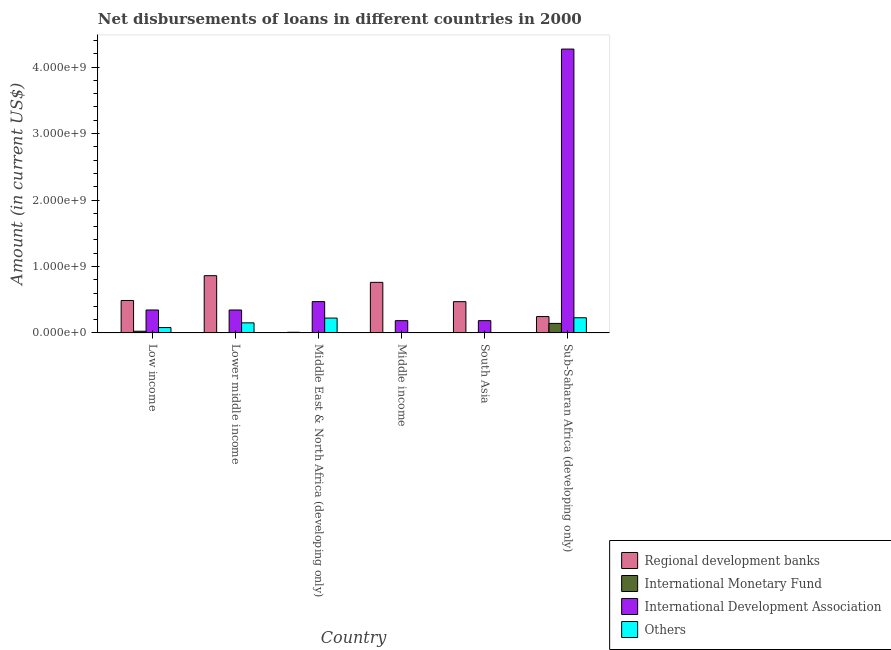Are the number of bars on each tick of the X-axis equal?
Give a very brief answer. No. How many bars are there on the 1st tick from the left?
Provide a short and direct response. 4. How many bars are there on the 6th tick from the right?
Your answer should be very brief. 4. What is the amount of loan disimbursed by regional development banks in Sub-Saharan Africa (developing only)?
Provide a succinct answer. 2.46e+08. Across all countries, what is the maximum amount of loan disimbursed by other organisations?
Offer a terse response. 2.28e+08. In which country was the amount of loan disimbursed by international monetary fund maximum?
Offer a terse response. Sub-Saharan Africa (developing only). What is the total amount of loan disimbursed by international monetary fund in the graph?
Offer a very short reply. 1.73e+08. What is the difference between the amount of loan disimbursed by regional development banks in Low income and that in Sub-Saharan Africa (developing only)?
Make the answer very short. 2.42e+08. What is the difference between the amount of loan disimbursed by international monetary fund in Low income and the amount of loan disimbursed by other organisations in Middle income?
Your answer should be compact. 2.57e+07. What is the average amount of loan disimbursed by regional development banks per country?
Keep it short and to the point. 4.73e+08. What is the difference between the amount of loan disimbursed by regional development banks and amount of loan disimbursed by international monetary fund in Low income?
Ensure brevity in your answer.  4.63e+08. In how many countries, is the amount of loan disimbursed by international development association greater than 4200000000 US$?
Give a very brief answer. 1. What is the ratio of the amount of loan disimbursed by regional development banks in Lower middle income to that in Sub-Saharan Africa (developing only)?
Ensure brevity in your answer.  3.5. Is the amount of loan disimbursed by international development association in Low income less than that in Middle income?
Offer a very short reply. No. Is the difference between the amount of loan disimbursed by regional development banks in Lower middle income and Sub-Saharan Africa (developing only) greater than the difference between the amount of loan disimbursed by other organisations in Lower middle income and Sub-Saharan Africa (developing only)?
Provide a short and direct response. Yes. What is the difference between the highest and the second highest amount of loan disimbursed by regional development banks?
Your answer should be compact. 1.01e+08. What is the difference between the highest and the lowest amount of loan disimbursed by other organisations?
Keep it short and to the point. 2.28e+08. In how many countries, is the amount of loan disimbursed by other organisations greater than the average amount of loan disimbursed by other organisations taken over all countries?
Offer a very short reply. 3. Is it the case that in every country, the sum of the amount of loan disimbursed by regional development banks and amount of loan disimbursed by international monetary fund is greater than the amount of loan disimbursed by international development association?
Ensure brevity in your answer.  No. Are the values on the major ticks of Y-axis written in scientific E-notation?
Your answer should be very brief. Yes. Does the graph contain any zero values?
Provide a short and direct response. Yes. Does the graph contain grids?
Your answer should be very brief. No. How are the legend labels stacked?
Provide a succinct answer. Vertical. What is the title of the graph?
Offer a very short reply. Net disbursements of loans in different countries in 2000. Does "Insurance services" appear as one of the legend labels in the graph?
Your answer should be compact. No. What is the label or title of the X-axis?
Provide a short and direct response. Country. What is the label or title of the Y-axis?
Your answer should be very brief. Amount (in current US$). What is the Amount (in current US$) in Regional development banks in Low income?
Your answer should be compact. 4.88e+08. What is the Amount (in current US$) of International Monetary Fund in Low income?
Your response must be concise. 2.57e+07. What is the Amount (in current US$) of International Development Association in Low income?
Ensure brevity in your answer.  3.45e+08. What is the Amount (in current US$) of Others in Low income?
Your answer should be very brief. 8.07e+07. What is the Amount (in current US$) in Regional development banks in Lower middle income?
Provide a short and direct response. 8.62e+08. What is the Amount (in current US$) of International Monetary Fund in Lower middle income?
Make the answer very short. 0. What is the Amount (in current US$) of International Development Association in Lower middle income?
Keep it short and to the point. 3.45e+08. What is the Amount (in current US$) in Others in Lower middle income?
Make the answer very short. 1.52e+08. What is the Amount (in current US$) in Regional development banks in Middle East & North Africa (developing only)?
Ensure brevity in your answer.  1.01e+07. What is the Amount (in current US$) in International Monetary Fund in Middle East & North Africa (developing only)?
Offer a terse response. 3.60e+06. What is the Amount (in current US$) of International Development Association in Middle East & North Africa (developing only)?
Provide a short and direct response. 4.71e+08. What is the Amount (in current US$) of Others in Middle East & North Africa (developing only)?
Your answer should be very brief. 2.24e+08. What is the Amount (in current US$) in Regional development banks in Middle income?
Your answer should be compact. 7.61e+08. What is the Amount (in current US$) of International Development Association in Middle income?
Give a very brief answer. 1.85e+08. What is the Amount (in current US$) in Regional development banks in South Asia?
Provide a succinct answer. 4.71e+08. What is the Amount (in current US$) in International Monetary Fund in South Asia?
Keep it short and to the point. 0. What is the Amount (in current US$) in International Development Association in South Asia?
Your response must be concise. 1.85e+08. What is the Amount (in current US$) of Others in South Asia?
Your answer should be compact. 0. What is the Amount (in current US$) of Regional development banks in Sub-Saharan Africa (developing only)?
Offer a terse response. 2.46e+08. What is the Amount (in current US$) in International Monetary Fund in Sub-Saharan Africa (developing only)?
Give a very brief answer. 1.43e+08. What is the Amount (in current US$) of International Development Association in Sub-Saharan Africa (developing only)?
Provide a short and direct response. 4.27e+09. What is the Amount (in current US$) in Others in Sub-Saharan Africa (developing only)?
Offer a very short reply. 2.28e+08. Across all countries, what is the maximum Amount (in current US$) in Regional development banks?
Keep it short and to the point. 8.62e+08. Across all countries, what is the maximum Amount (in current US$) of International Monetary Fund?
Give a very brief answer. 1.43e+08. Across all countries, what is the maximum Amount (in current US$) of International Development Association?
Provide a succinct answer. 4.27e+09. Across all countries, what is the maximum Amount (in current US$) in Others?
Provide a short and direct response. 2.28e+08. Across all countries, what is the minimum Amount (in current US$) in Regional development banks?
Provide a short and direct response. 1.01e+07. Across all countries, what is the minimum Amount (in current US$) of International Development Association?
Keep it short and to the point. 1.85e+08. Across all countries, what is the minimum Amount (in current US$) of Others?
Your response must be concise. 0. What is the total Amount (in current US$) in Regional development banks in the graph?
Make the answer very short. 2.84e+09. What is the total Amount (in current US$) of International Monetary Fund in the graph?
Your answer should be very brief. 1.73e+08. What is the total Amount (in current US$) in International Development Association in the graph?
Your answer should be very brief. 5.80e+09. What is the total Amount (in current US$) of Others in the graph?
Keep it short and to the point. 6.85e+08. What is the difference between the Amount (in current US$) in Regional development banks in Low income and that in Lower middle income?
Keep it short and to the point. -3.73e+08. What is the difference between the Amount (in current US$) in International Development Association in Low income and that in Lower middle income?
Give a very brief answer. 0. What is the difference between the Amount (in current US$) in Others in Low income and that in Lower middle income?
Give a very brief answer. -7.11e+07. What is the difference between the Amount (in current US$) in Regional development banks in Low income and that in Middle East & North Africa (developing only)?
Your answer should be very brief. 4.78e+08. What is the difference between the Amount (in current US$) of International Monetary Fund in Low income and that in Middle East & North Africa (developing only)?
Offer a very short reply. 2.22e+07. What is the difference between the Amount (in current US$) in International Development Association in Low income and that in Middle East & North Africa (developing only)?
Your response must be concise. -1.26e+08. What is the difference between the Amount (in current US$) of Others in Low income and that in Middle East & North Africa (developing only)?
Ensure brevity in your answer.  -1.43e+08. What is the difference between the Amount (in current US$) in Regional development banks in Low income and that in Middle income?
Ensure brevity in your answer.  -2.73e+08. What is the difference between the Amount (in current US$) in International Development Association in Low income and that in Middle income?
Provide a short and direct response. 1.60e+08. What is the difference between the Amount (in current US$) in Regional development banks in Low income and that in South Asia?
Keep it short and to the point. 1.75e+07. What is the difference between the Amount (in current US$) in International Development Association in Low income and that in South Asia?
Your answer should be very brief. 1.60e+08. What is the difference between the Amount (in current US$) of Regional development banks in Low income and that in Sub-Saharan Africa (developing only)?
Offer a terse response. 2.42e+08. What is the difference between the Amount (in current US$) in International Monetary Fund in Low income and that in Sub-Saharan Africa (developing only)?
Offer a terse response. -1.18e+08. What is the difference between the Amount (in current US$) of International Development Association in Low income and that in Sub-Saharan Africa (developing only)?
Offer a terse response. -3.93e+09. What is the difference between the Amount (in current US$) in Others in Low income and that in Sub-Saharan Africa (developing only)?
Your answer should be very brief. -1.48e+08. What is the difference between the Amount (in current US$) in Regional development banks in Lower middle income and that in Middle East & North Africa (developing only)?
Offer a very short reply. 8.52e+08. What is the difference between the Amount (in current US$) in International Development Association in Lower middle income and that in Middle East & North Africa (developing only)?
Ensure brevity in your answer.  -1.26e+08. What is the difference between the Amount (in current US$) of Others in Lower middle income and that in Middle East & North Africa (developing only)?
Offer a terse response. -7.19e+07. What is the difference between the Amount (in current US$) of Regional development banks in Lower middle income and that in Middle income?
Keep it short and to the point. 1.01e+08. What is the difference between the Amount (in current US$) in International Development Association in Lower middle income and that in Middle income?
Your response must be concise. 1.60e+08. What is the difference between the Amount (in current US$) of Regional development banks in Lower middle income and that in South Asia?
Keep it short and to the point. 3.91e+08. What is the difference between the Amount (in current US$) in International Development Association in Lower middle income and that in South Asia?
Your response must be concise. 1.60e+08. What is the difference between the Amount (in current US$) of Regional development banks in Lower middle income and that in Sub-Saharan Africa (developing only)?
Ensure brevity in your answer.  6.15e+08. What is the difference between the Amount (in current US$) in International Development Association in Lower middle income and that in Sub-Saharan Africa (developing only)?
Make the answer very short. -3.93e+09. What is the difference between the Amount (in current US$) of Others in Lower middle income and that in Sub-Saharan Africa (developing only)?
Offer a terse response. -7.66e+07. What is the difference between the Amount (in current US$) of Regional development banks in Middle East & North Africa (developing only) and that in Middle income?
Your response must be concise. -7.51e+08. What is the difference between the Amount (in current US$) of International Development Association in Middle East & North Africa (developing only) and that in Middle income?
Provide a succinct answer. 2.86e+08. What is the difference between the Amount (in current US$) of Regional development banks in Middle East & North Africa (developing only) and that in South Asia?
Provide a short and direct response. -4.61e+08. What is the difference between the Amount (in current US$) in International Development Association in Middle East & North Africa (developing only) and that in South Asia?
Your answer should be compact. 2.86e+08. What is the difference between the Amount (in current US$) in Regional development banks in Middle East & North Africa (developing only) and that in Sub-Saharan Africa (developing only)?
Offer a terse response. -2.36e+08. What is the difference between the Amount (in current US$) in International Monetary Fund in Middle East & North Africa (developing only) and that in Sub-Saharan Africa (developing only)?
Your response must be concise. -1.40e+08. What is the difference between the Amount (in current US$) of International Development Association in Middle East & North Africa (developing only) and that in Sub-Saharan Africa (developing only)?
Provide a succinct answer. -3.80e+09. What is the difference between the Amount (in current US$) in Others in Middle East & North Africa (developing only) and that in Sub-Saharan Africa (developing only)?
Offer a very short reply. -4.69e+06. What is the difference between the Amount (in current US$) of Regional development banks in Middle income and that in South Asia?
Make the answer very short. 2.90e+08. What is the difference between the Amount (in current US$) in International Development Association in Middle income and that in South Asia?
Your response must be concise. 0. What is the difference between the Amount (in current US$) of Regional development banks in Middle income and that in Sub-Saharan Africa (developing only)?
Your answer should be compact. 5.15e+08. What is the difference between the Amount (in current US$) in International Development Association in Middle income and that in Sub-Saharan Africa (developing only)?
Keep it short and to the point. -4.09e+09. What is the difference between the Amount (in current US$) of Regional development banks in South Asia and that in Sub-Saharan Africa (developing only)?
Ensure brevity in your answer.  2.24e+08. What is the difference between the Amount (in current US$) of International Development Association in South Asia and that in Sub-Saharan Africa (developing only)?
Ensure brevity in your answer.  -4.09e+09. What is the difference between the Amount (in current US$) in Regional development banks in Low income and the Amount (in current US$) in International Development Association in Lower middle income?
Provide a short and direct response. 1.43e+08. What is the difference between the Amount (in current US$) of Regional development banks in Low income and the Amount (in current US$) of Others in Lower middle income?
Keep it short and to the point. 3.37e+08. What is the difference between the Amount (in current US$) of International Monetary Fund in Low income and the Amount (in current US$) of International Development Association in Lower middle income?
Give a very brief answer. -3.20e+08. What is the difference between the Amount (in current US$) of International Monetary Fund in Low income and the Amount (in current US$) of Others in Lower middle income?
Your answer should be very brief. -1.26e+08. What is the difference between the Amount (in current US$) of International Development Association in Low income and the Amount (in current US$) of Others in Lower middle income?
Provide a short and direct response. 1.93e+08. What is the difference between the Amount (in current US$) of Regional development banks in Low income and the Amount (in current US$) of International Monetary Fund in Middle East & North Africa (developing only)?
Keep it short and to the point. 4.85e+08. What is the difference between the Amount (in current US$) in Regional development banks in Low income and the Amount (in current US$) in International Development Association in Middle East & North Africa (developing only)?
Your response must be concise. 1.71e+07. What is the difference between the Amount (in current US$) in Regional development banks in Low income and the Amount (in current US$) in Others in Middle East & North Africa (developing only)?
Your response must be concise. 2.65e+08. What is the difference between the Amount (in current US$) in International Monetary Fund in Low income and the Amount (in current US$) in International Development Association in Middle East & North Africa (developing only)?
Your response must be concise. -4.46e+08. What is the difference between the Amount (in current US$) in International Monetary Fund in Low income and the Amount (in current US$) in Others in Middle East & North Africa (developing only)?
Give a very brief answer. -1.98e+08. What is the difference between the Amount (in current US$) in International Development Association in Low income and the Amount (in current US$) in Others in Middle East & North Africa (developing only)?
Provide a succinct answer. 1.22e+08. What is the difference between the Amount (in current US$) in Regional development banks in Low income and the Amount (in current US$) in International Development Association in Middle income?
Provide a succinct answer. 3.03e+08. What is the difference between the Amount (in current US$) of International Monetary Fund in Low income and the Amount (in current US$) of International Development Association in Middle income?
Make the answer very short. -1.59e+08. What is the difference between the Amount (in current US$) of Regional development banks in Low income and the Amount (in current US$) of International Development Association in South Asia?
Offer a very short reply. 3.03e+08. What is the difference between the Amount (in current US$) of International Monetary Fund in Low income and the Amount (in current US$) of International Development Association in South Asia?
Offer a terse response. -1.59e+08. What is the difference between the Amount (in current US$) in Regional development banks in Low income and the Amount (in current US$) in International Monetary Fund in Sub-Saharan Africa (developing only)?
Your answer should be very brief. 3.45e+08. What is the difference between the Amount (in current US$) of Regional development banks in Low income and the Amount (in current US$) of International Development Association in Sub-Saharan Africa (developing only)?
Your response must be concise. -3.78e+09. What is the difference between the Amount (in current US$) in Regional development banks in Low income and the Amount (in current US$) in Others in Sub-Saharan Africa (developing only)?
Provide a succinct answer. 2.60e+08. What is the difference between the Amount (in current US$) of International Monetary Fund in Low income and the Amount (in current US$) of International Development Association in Sub-Saharan Africa (developing only)?
Your answer should be very brief. -4.25e+09. What is the difference between the Amount (in current US$) in International Monetary Fund in Low income and the Amount (in current US$) in Others in Sub-Saharan Africa (developing only)?
Give a very brief answer. -2.03e+08. What is the difference between the Amount (in current US$) in International Development Association in Low income and the Amount (in current US$) in Others in Sub-Saharan Africa (developing only)?
Offer a terse response. 1.17e+08. What is the difference between the Amount (in current US$) in Regional development banks in Lower middle income and the Amount (in current US$) in International Monetary Fund in Middle East & North Africa (developing only)?
Provide a short and direct response. 8.58e+08. What is the difference between the Amount (in current US$) in Regional development banks in Lower middle income and the Amount (in current US$) in International Development Association in Middle East & North Africa (developing only)?
Provide a short and direct response. 3.90e+08. What is the difference between the Amount (in current US$) in Regional development banks in Lower middle income and the Amount (in current US$) in Others in Middle East & North Africa (developing only)?
Provide a succinct answer. 6.38e+08. What is the difference between the Amount (in current US$) in International Development Association in Lower middle income and the Amount (in current US$) in Others in Middle East & North Africa (developing only)?
Offer a terse response. 1.22e+08. What is the difference between the Amount (in current US$) in Regional development banks in Lower middle income and the Amount (in current US$) in International Development Association in Middle income?
Ensure brevity in your answer.  6.77e+08. What is the difference between the Amount (in current US$) in Regional development banks in Lower middle income and the Amount (in current US$) in International Development Association in South Asia?
Make the answer very short. 6.77e+08. What is the difference between the Amount (in current US$) of Regional development banks in Lower middle income and the Amount (in current US$) of International Monetary Fund in Sub-Saharan Africa (developing only)?
Your answer should be compact. 7.18e+08. What is the difference between the Amount (in current US$) in Regional development banks in Lower middle income and the Amount (in current US$) in International Development Association in Sub-Saharan Africa (developing only)?
Your response must be concise. -3.41e+09. What is the difference between the Amount (in current US$) in Regional development banks in Lower middle income and the Amount (in current US$) in Others in Sub-Saharan Africa (developing only)?
Your answer should be compact. 6.33e+08. What is the difference between the Amount (in current US$) in International Development Association in Lower middle income and the Amount (in current US$) in Others in Sub-Saharan Africa (developing only)?
Provide a succinct answer. 1.17e+08. What is the difference between the Amount (in current US$) in Regional development banks in Middle East & North Africa (developing only) and the Amount (in current US$) in International Development Association in Middle income?
Keep it short and to the point. -1.75e+08. What is the difference between the Amount (in current US$) in International Monetary Fund in Middle East & North Africa (developing only) and the Amount (in current US$) in International Development Association in Middle income?
Provide a succinct answer. -1.81e+08. What is the difference between the Amount (in current US$) in Regional development banks in Middle East & North Africa (developing only) and the Amount (in current US$) in International Development Association in South Asia?
Provide a short and direct response. -1.75e+08. What is the difference between the Amount (in current US$) in International Monetary Fund in Middle East & North Africa (developing only) and the Amount (in current US$) in International Development Association in South Asia?
Make the answer very short. -1.81e+08. What is the difference between the Amount (in current US$) of Regional development banks in Middle East & North Africa (developing only) and the Amount (in current US$) of International Monetary Fund in Sub-Saharan Africa (developing only)?
Give a very brief answer. -1.33e+08. What is the difference between the Amount (in current US$) of Regional development banks in Middle East & North Africa (developing only) and the Amount (in current US$) of International Development Association in Sub-Saharan Africa (developing only)?
Give a very brief answer. -4.26e+09. What is the difference between the Amount (in current US$) in Regional development banks in Middle East & North Africa (developing only) and the Amount (in current US$) in Others in Sub-Saharan Africa (developing only)?
Provide a succinct answer. -2.18e+08. What is the difference between the Amount (in current US$) in International Monetary Fund in Middle East & North Africa (developing only) and the Amount (in current US$) in International Development Association in Sub-Saharan Africa (developing only)?
Make the answer very short. -4.27e+09. What is the difference between the Amount (in current US$) in International Monetary Fund in Middle East & North Africa (developing only) and the Amount (in current US$) in Others in Sub-Saharan Africa (developing only)?
Offer a terse response. -2.25e+08. What is the difference between the Amount (in current US$) of International Development Association in Middle East & North Africa (developing only) and the Amount (in current US$) of Others in Sub-Saharan Africa (developing only)?
Give a very brief answer. 2.43e+08. What is the difference between the Amount (in current US$) in Regional development banks in Middle income and the Amount (in current US$) in International Development Association in South Asia?
Offer a terse response. 5.76e+08. What is the difference between the Amount (in current US$) of Regional development banks in Middle income and the Amount (in current US$) of International Monetary Fund in Sub-Saharan Africa (developing only)?
Your answer should be compact. 6.18e+08. What is the difference between the Amount (in current US$) of Regional development banks in Middle income and the Amount (in current US$) of International Development Association in Sub-Saharan Africa (developing only)?
Provide a succinct answer. -3.51e+09. What is the difference between the Amount (in current US$) in Regional development banks in Middle income and the Amount (in current US$) in Others in Sub-Saharan Africa (developing only)?
Offer a terse response. 5.33e+08. What is the difference between the Amount (in current US$) in International Development Association in Middle income and the Amount (in current US$) in Others in Sub-Saharan Africa (developing only)?
Offer a terse response. -4.35e+07. What is the difference between the Amount (in current US$) in Regional development banks in South Asia and the Amount (in current US$) in International Monetary Fund in Sub-Saharan Africa (developing only)?
Keep it short and to the point. 3.28e+08. What is the difference between the Amount (in current US$) of Regional development banks in South Asia and the Amount (in current US$) of International Development Association in Sub-Saharan Africa (developing only)?
Provide a short and direct response. -3.80e+09. What is the difference between the Amount (in current US$) of Regional development banks in South Asia and the Amount (in current US$) of Others in Sub-Saharan Africa (developing only)?
Make the answer very short. 2.42e+08. What is the difference between the Amount (in current US$) in International Development Association in South Asia and the Amount (in current US$) in Others in Sub-Saharan Africa (developing only)?
Your answer should be compact. -4.35e+07. What is the average Amount (in current US$) in Regional development banks per country?
Your answer should be very brief. 4.73e+08. What is the average Amount (in current US$) of International Monetary Fund per country?
Keep it short and to the point. 2.88e+07. What is the average Amount (in current US$) in International Development Association per country?
Your response must be concise. 9.67e+08. What is the average Amount (in current US$) in Others per country?
Offer a very short reply. 1.14e+08. What is the difference between the Amount (in current US$) of Regional development banks and Amount (in current US$) of International Monetary Fund in Low income?
Make the answer very short. 4.63e+08. What is the difference between the Amount (in current US$) of Regional development banks and Amount (in current US$) of International Development Association in Low income?
Give a very brief answer. 1.43e+08. What is the difference between the Amount (in current US$) in Regional development banks and Amount (in current US$) in Others in Low income?
Keep it short and to the point. 4.08e+08. What is the difference between the Amount (in current US$) in International Monetary Fund and Amount (in current US$) in International Development Association in Low income?
Make the answer very short. -3.20e+08. What is the difference between the Amount (in current US$) of International Monetary Fund and Amount (in current US$) of Others in Low income?
Ensure brevity in your answer.  -5.50e+07. What is the difference between the Amount (in current US$) in International Development Association and Amount (in current US$) in Others in Low income?
Offer a terse response. 2.65e+08. What is the difference between the Amount (in current US$) of Regional development banks and Amount (in current US$) of International Development Association in Lower middle income?
Provide a succinct answer. 5.16e+08. What is the difference between the Amount (in current US$) in Regional development banks and Amount (in current US$) in Others in Lower middle income?
Offer a very short reply. 7.10e+08. What is the difference between the Amount (in current US$) in International Development Association and Amount (in current US$) in Others in Lower middle income?
Make the answer very short. 1.93e+08. What is the difference between the Amount (in current US$) in Regional development banks and Amount (in current US$) in International Monetary Fund in Middle East & North Africa (developing only)?
Give a very brief answer. 6.48e+06. What is the difference between the Amount (in current US$) in Regional development banks and Amount (in current US$) in International Development Association in Middle East & North Africa (developing only)?
Make the answer very short. -4.61e+08. What is the difference between the Amount (in current US$) of Regional development banks and Amount (in current US$) of Others in Middle East & North Africa (developing only)?
Ensure brevity in your answer.  -2.14e+08. What is the difference between the Amount (in current US$) of International Monetary Fund and Amount (in current US$) of International Development Association in Middle East & North Africa (developing only)?
Your answer should be very brief. -4.68e+08. What is the difference between the Amount (in current US$) of International Monetary Fund and Amount (in current US$) of Others in Middle East & North Africa (developing only)?
Offer a terse response. -2.20e+08. What is the difference between the Amount (in current US$) in International Development Association and Amount (in current US$) in Others in Middle East & North Africa (developing only)?
Make the answer very short. 2.48e+08. What is the difference between the Amount (in current US$) in Regional development banks and Amount (in current US$) in International Development Association in Middle income?
Give a very brief answer. 5.76e+08. What is the difference between the Amount (in current US$) in Regional development banks and Amount (in current US$) in International Development Association in South Asia?
Your response must be concise. 2.86e+08. What is the difference between the Amount (in current US$) in Regional development banks and Amount (in current US$) in International Monetary Fund in Sub-Saharan Africa (developing only)?
Offer a terse response. 1.03e+08. What is the difference between the Amount (in current US$) of Regional development banks and Amount (in current US$) of International Development Association in Sub-Saharan Africa (developing only)?
Keep it short and to the point. -4.03e+09. What is the difference between the Amount (in current US$) in Regional development banks and Amount (in current US$) in Others in Sub-Saharan Africa (developing only)?
Ensure brevity in your answer.  1.79e+07. What is the difference between the Amount (in current US$) in International Monetary Fund and Amount (in current US$) in International Development Association in Sub-Saharan Africa (developing only)?
Ensure brevity in your answer.  -4.13e+09. What is the difference between the Amount (in current US$) of International Monetary Fund and Amount (in current US$) of Others in Sub-Saharan Africa (developing only)?
Your response must be concise. -8.51e+07. What is the difference between the Amount (in current US$) in International Development Association and Amount (in current US$) in Others in Sub-Saharan Africa (developing only)?
Your answer should be very brief. 4.04e+09. What is the ratio of the Amount (in current US$) of Regional development banks in Low income to that in Lower middle income?
Make the answer very short. 0.57. What is the ratio of the Amount (in current US$) of International Development Association in Low income to that in Lower middle income?
Offer a very short reply. 1. What is the ratio of the Amount (in current US$) of Others in Low income to that in Lower middle income?
Ensure brevity in your answer.  0.53. What is the ratio of the Amount (in current US$) of Regional development banks in Low income to that in Middle East & North Africa (developing only)?
Your answer should be compact. 48.46. What is the ratio of the Amount (in current US$) of International Monetary Fund in Low income to that in Middle East & North Africa (developing only)?
Make the answer very short. 7.16. What is the ratio of the Amount (in current US$) in International Development Association in Low income to that in Middle East & North Africa (developing only)?
Provide a succinct answer. 0.73. What is the ratio of the Amount (in current US$) of Others in Low income to that in Middle East & North Africa (developing only)?
Your answer should be very brief. 0.36. What is the ratio of the Amount (in current US$) in Regional development banks in Low income to that in Middle income?
Offer a very short reply. 0.64. What is the ratio of the Amount (in current US$) in International Development Association in Low income to that in Middle income?
Provide a short and direct response. 1.87. What is the ratio of the Amount (in current US$) in Regional development banks in Low income to that in South Asia?
Offer a very short reply. 1.04. What is the ratio of the Amount (in current US$) of International Development Association in Low income to that in South Asia?
Your response must be concise. 1.87. What is the ratio of the Amount (in current US$) in Regional development banks in Low income to that in Sub-Saharan Africa (developing only)?
Offer a terse response. 1.98. What is the ratio of the Amount (in current US$) in International Monetary Fund in Low income to that in Sub-Saharan Africa (developing only)?
Provide a succinct answer. 0.18. What is the ratio of the Amount (in current US$) of International Development Association in Low income to that in Sub-Saharan Africa (developing only)?
Keep it short and to the point. 0.08. What is the ratio of the Amount (in current US$) in Others in Low income to that in Sub-Saharan Africa (developing only)?
Provide a succinct answer. 0.35. What is the ratio of the Amount (in current US$) of Regional development banks in Lower middle income to that in Middle East & North Africa (developing only)?
Keep it short and to the point. 85.49. What is the ratio of the Amount (in current US$) of International Development Association in Lower middle income to that in Middle East & North Africa (developing only)?
Your response must be concise. 0.73. What is the ratio of the Amount (in current US$) of Others in Lower middle income to that in Middle East & North Africa (developing only)?
Provide a succinct answer. 0.68. What is the ratio of the Amount (in current US$) of Regional development banks in Lower middle income to that in Middle income?
Ensure brevity in your answer.  1.13. What is the ratio of the Amount (in current US$) in International Development Association in Lower middle income to that in Middle income?
Offer a very short reply. 1.87. What is the ratio of the Amount (in current US$) in Regional development banks in Lower middle income to that in South Asia?
Keep it short and to the point. 1.83. What is the ratio of the Amount (in current US$) in International Development Association in Lower middle income to that in South Asia?
Your answer should be compact. 1.87. What is the ratio of the Amount (in current US$) in Regional development banks in Lower middle income to that in Sub-Saharan Africa (developing only)?
Your answer should be compact. 3.5. What is the ratio of the Amount (in current US$) of International Development Association in Lower middle income to that in Sub-Saharan Africa (developing only)?
Your answer should be very brief. 0.08. What is the ratio of the Amount (in current US$) of Others in Lower middle income to that in Sub-Saharan Africa (developing only)?
Keep it short and to the point. 0.66. What is the ratio of the Amount (in current US$) in Regional development banks in Middle East & North Africa (developing only) to that in Middle income?
Keep it short and to the point. 0.01. What is the ratio of the Amount (in current US$) of International Development Association in Middle East & North Africa (developing only) to that in Middle income?
Offer a very short reply. 2.55. What is the ratio of the Amount (in current US$) of Regional development banks in Middle East & North Africa (developing only) to that in South Asia?
Offer a very short reply. 0.02. What is the ratio of the Amount (in current US$) of International Development Association in Middle East & North Africa (developing only) to that in South Asia?
Your answer should be compact. 2.55. What is the ratio of the Amount (in current US$) in Regional development banks in Middle East & North Africa (developing only) to that in Sub-Saharan Africa (developing only)?
Provide a succinct answer. 0.04. What is the ratio of the Amount (in current US$) in International Monetary Fund in Middle East & North Africa (developing only) to that in Sub-Saharan Africa (developing only)?
Your answer should be compact. 0.03. What is the ratio of the Amount (in current US$) in International Development Association in Middle East & North Africa (developing only) to that in Sub-Saharan Africa (developing only)?
Your answer should be very brief. 0.11. What is the ratio of the Amount (in current US$) of Others in Middle East & North Africa (developing only) to that in Sub-Saharan Africa (developing only)?
Offer a very short reply. 0.98. What is the ratio of the Amount (in current US$) of Regional development banks in Middle income to that in South Asia?
Offer a very short reply. 1.62. What is the ratio of the Amount (in current US$) of Regional development banks in Middle income to that in Sub-Saharan Africa (developing only)?
Offer a terse response. 3.09. What is the ratio of the Amount (in current US$) in International Development Association in Middle income to that in Sub-Saharan Africa (developing only)?
Ensure brevity in your answer.  0.04. What is the ratio of the Amount (in current US$) of Regional development banks in South Asia to that in Sub-Saharan Africa (developing only)?
Provide a short and direct response. 1.91. What is the ratio of the Amount (in current US$) in International Development Association in South Asia to that in Sub-Saharan Africa (developing only)?
Provide a short and direct response. 0.04. What is the difference between the highest and the second highest Amount (in current US$) in Regional development banks?
Provide a short and direct response. 1.01e+08. What is the difference between the highest and the second highest Amount (in current US$) in International Monetary Fund?
Offer a very short reply. 1.18e+08. What is the difference between the highest and the second highest Amount (in current US$) of International Development Association?
Your response must be concise. 3.80e+09. What is the difference between the highest and the second highest Amount (in current US$) in Others?
Offer a very short reply. 4.69e+06. What is the difference between the highest and the lowest Amount (in current US$) of Regional development banks?
Make the answer very short. 8.52e+08. What is the difference between the highest and the lowest Amount (in current US$) of International Monetary Fund?
Keep it short and to the point. 1.43e+08. What is the difference between the highest and the lowest Amount (in current US$) of International Development Association?
Make the answer very short. 4.09e+09. What is the difference between the highest and the lowest Amount (in current US$) in Others?
Give a very brief answer. 2.28e+08. 